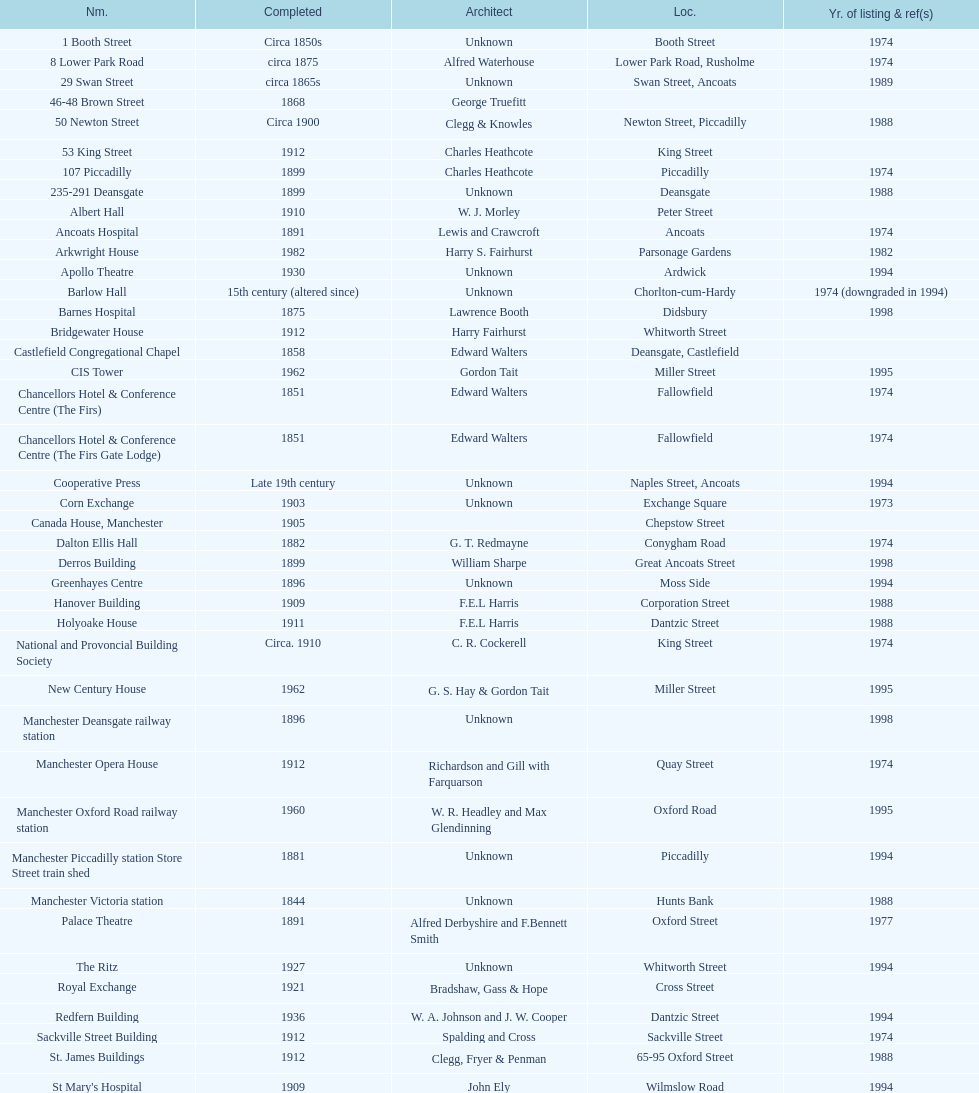Was charles heathcote the architect of ancoats hospital and apollo theatre? No. 